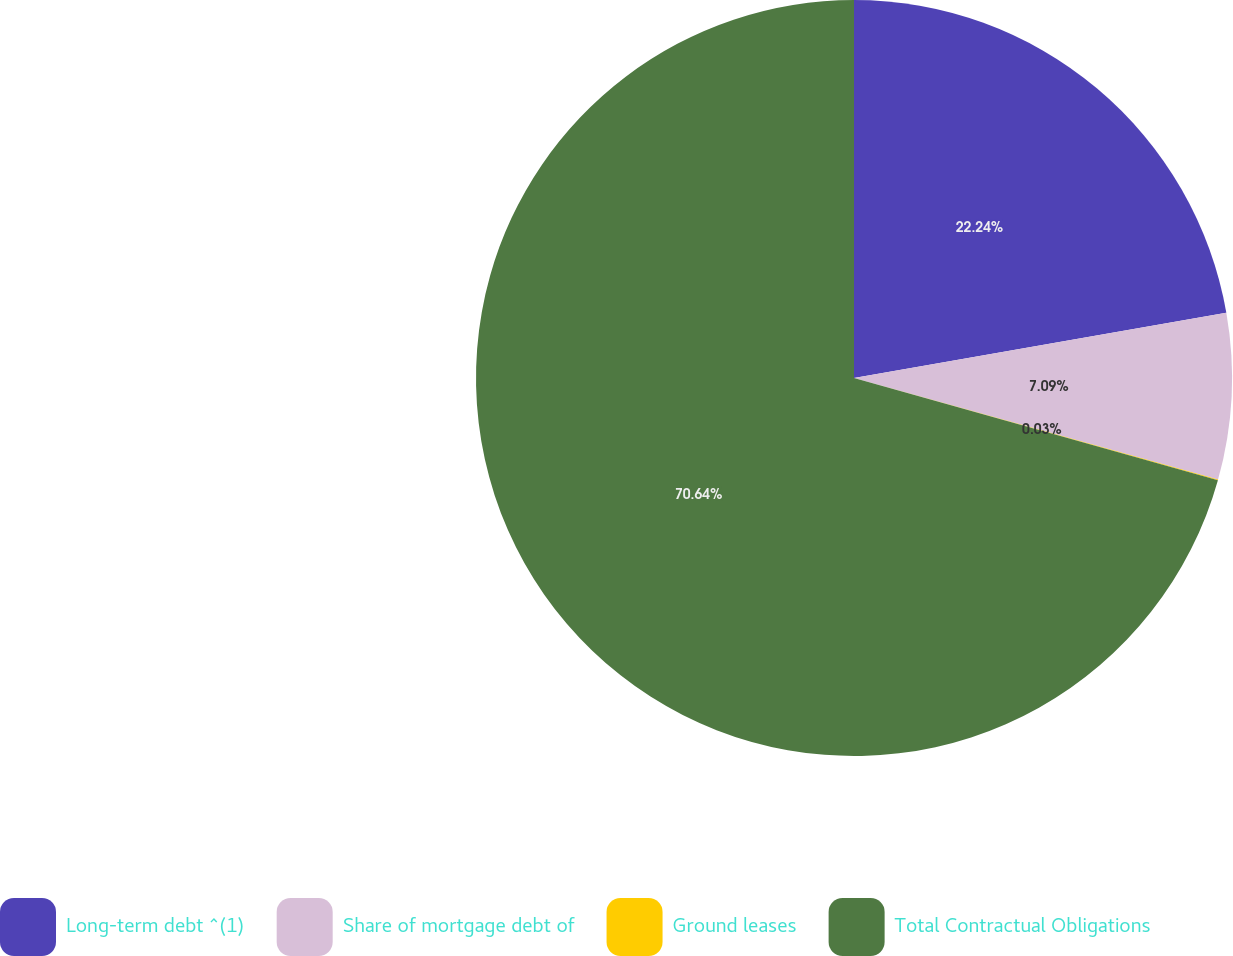Convert chart to OTSL. <chart><loc_0><loc_0><loc_500><loc_500><pie_chart><fcel>Long-term debt ^(1)<fcel>Share of mortgage debt of<fcel>Ground leases<fcel>Total Contractual Obligations<nl><fcel>22.24%<fcel>7.09%<fcel>0.03%<fcel>70.64%<nl></chart> 